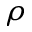<formula> <loc_0><loc_0><loc_500><loc_500>\rho</formula> 